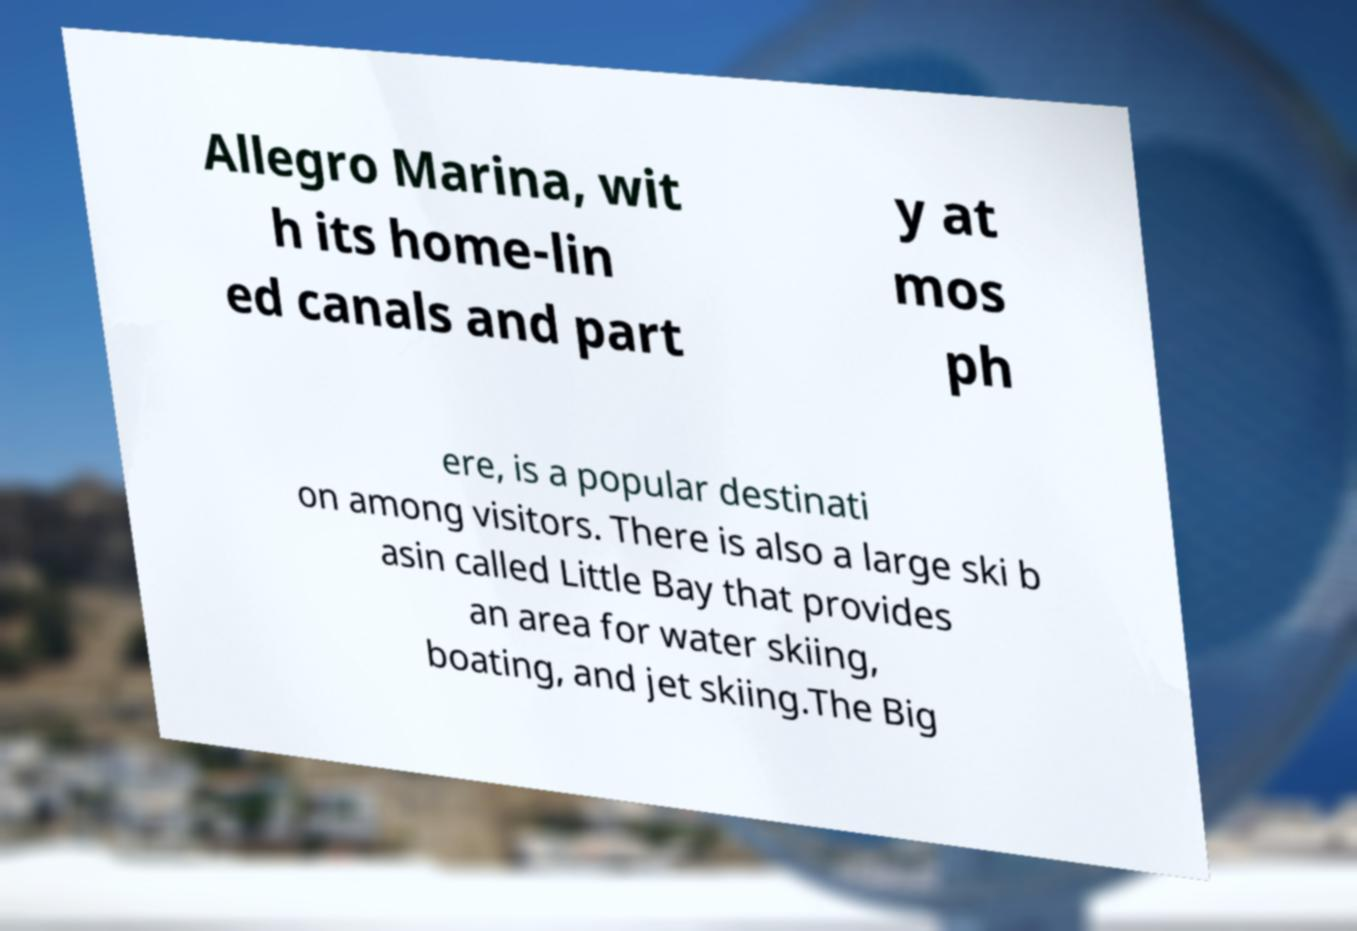Could you assist in decoding the text presented in this image and type it out clearly? Allegro Marina, wit h its home-lin ed canals and part y at mos ph ere, is a popular destinati on among visitors. There is also a large ski b asin called Little Bay that provides an area for water skiing, boating, and jet skiing.The Big 